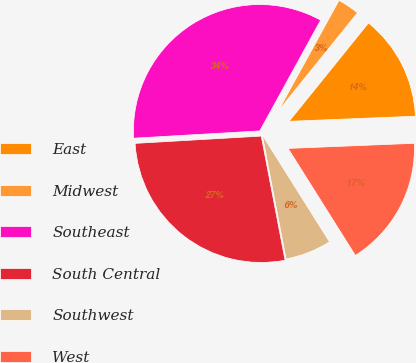Convert chart. <chart><loc_0><loc_0><loc_500><loc_500><pie_chart><fcel>East<fcel>Midwest<fcel>Southeast<fcel>South Central<fcel>Southwest<fcel>West<nl><fcel>13.55%<fcel>2.81%<fcel>33.92%<fcel>27.1%<fcel>5.92%<fcel>16.71%<nl></chart> 